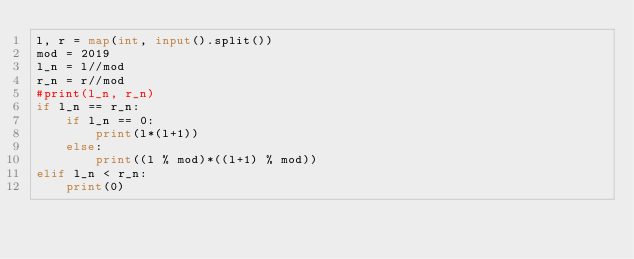Convert code to text. <code><loc_0><loc_0><loc_500><loc_500><_Python_>l, r = map(int, input().split())
mod = 2019
l_n = l//mod
r_n = r//mod
#print(l_n, r_n)
if l_n == r_n:
    if l_n == 0:
        print(l*(l+1))
    else:
        print((l % mod)*((l+1) % mod))
elif l_n < r_n:
    print(0)
</code> 